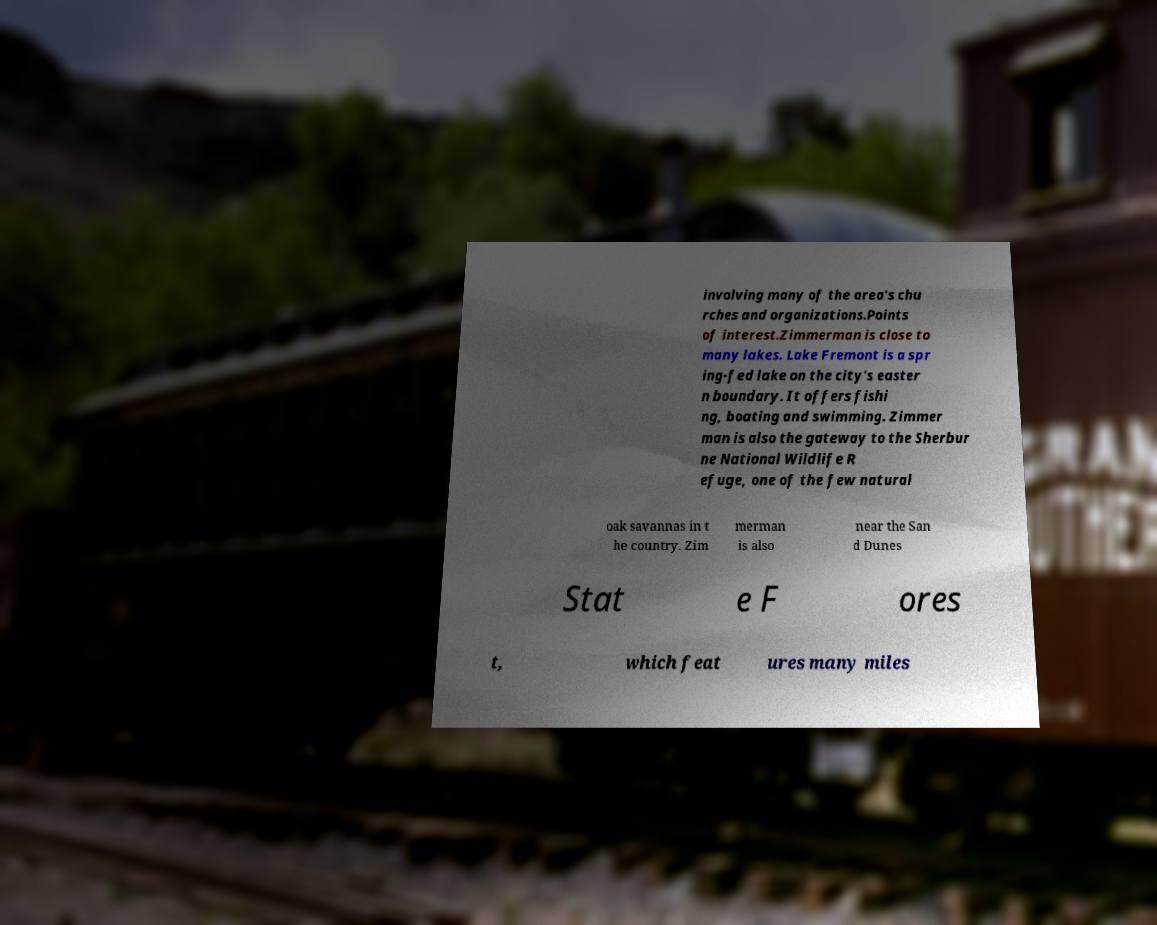There's text embedded in this image that I need extracted. Can you transcribe it verbatim? involving many of the area's chu rches and organizations.Points of interest.Zimmerman is close to many lakes. Lake Fremont is a spr ing-fed lake on the city's easter n boundary. It offers fishi ng, boating and swimming. Zimmer man is also the gateway to the Sherbur ne National Wildlife R efuge, one of the few natural oak savannas in t he country. Zim merman is also near the San d Dunes Stat e F ores t, which feat ures many miles 